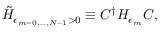Convert formula to latex. <formula><loc_0><loc_0><loc_500><loc_500>\tilde { H } _ { \epsilon _ { m = 0 , \dots , N - 1 } > 0 } \equiv C ^ { \dagger } H _ { \epsilon _ { m } } C ,</formula> 